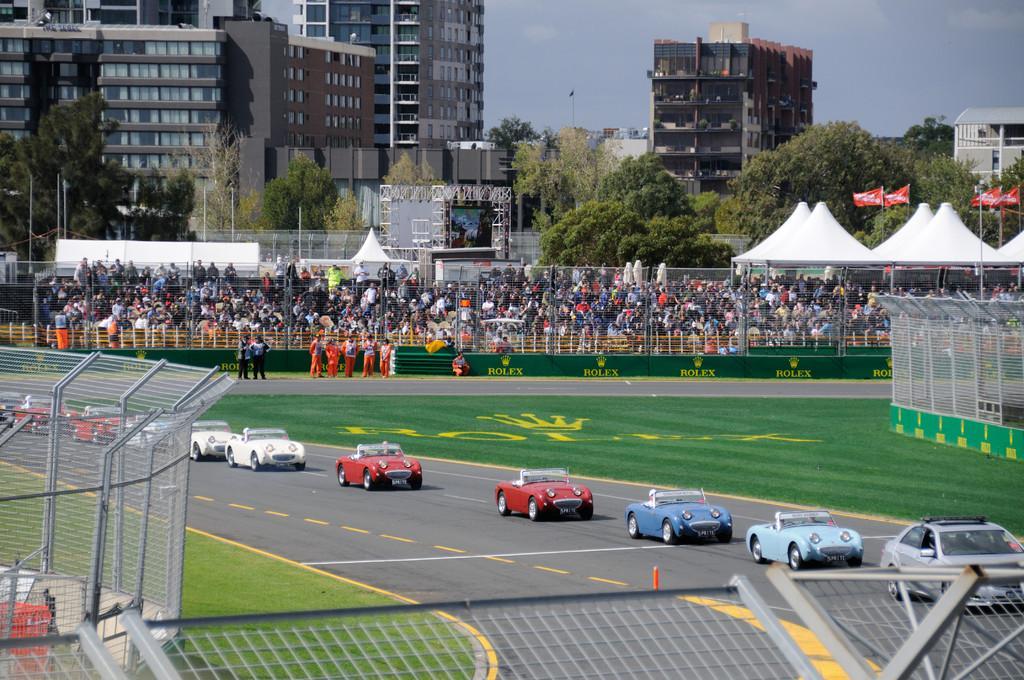In one or two sentences, can you explain what this image depicts? In this image in the front there is fence. In the center there are cars moving on the road, there's grass on the ground. In the background there are persons, there are tents, flags, trees and buildings. On the right side there is fence which is visible. 